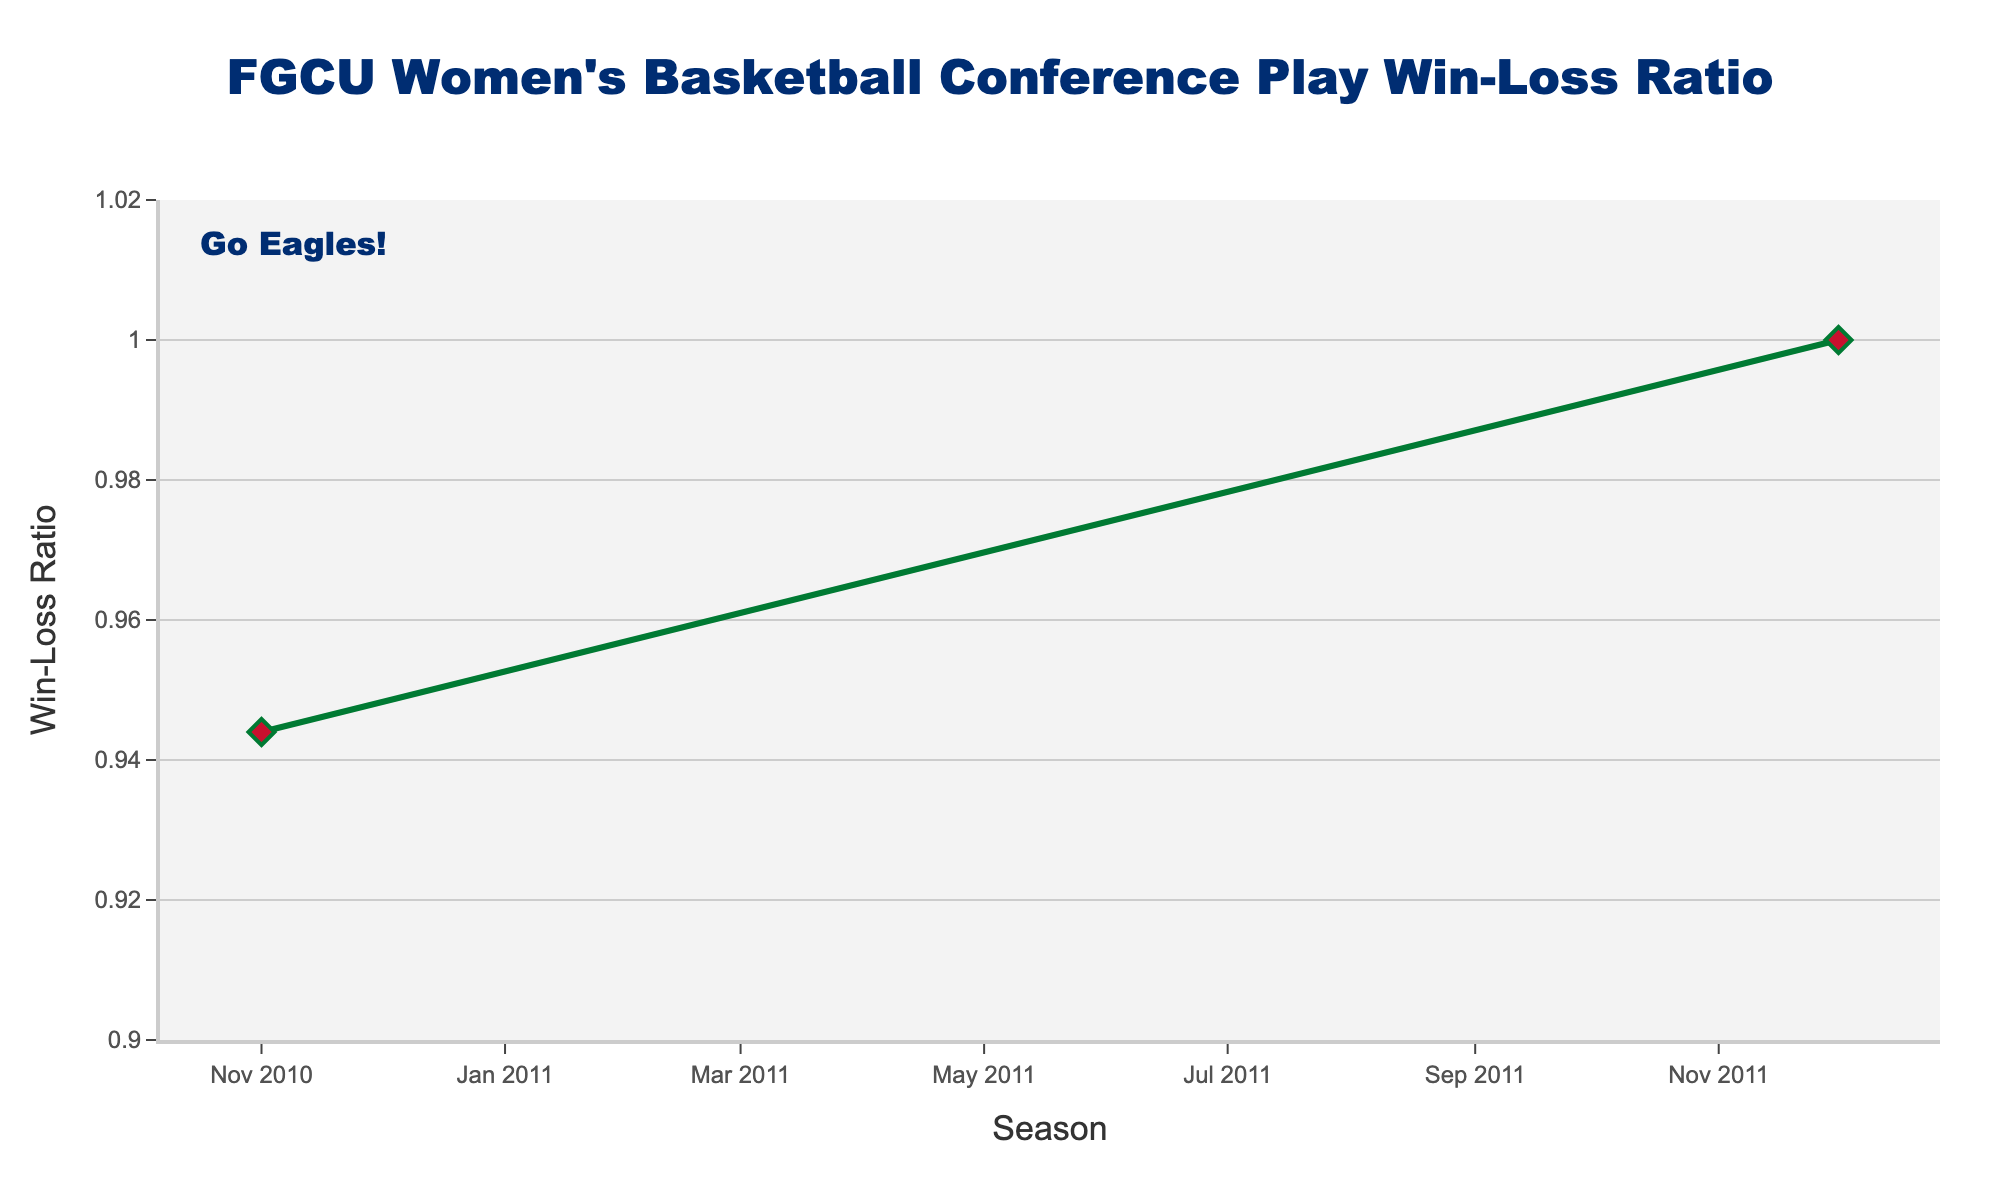What is the win-loss ratio for the 2014-15 season? Locate the point corresponding to the 2014-15 season on the x-axis and find the y-axis value, which is 1.000
Answer: 1.000 How many seasons have a perfect win-loss ratio of 1.000? Identify all the points on the line chart that are at the 1.000 mark on the y-axis (2011-12, 2012-13, 2014-15, 2015-16, 2018-19). There are five such seasons
Answer: 5 Which season has the lowest win-loss ratio? Find the point with the lowest y-axis value in the entire chart. The lowest win-loss ratio is 0.929, seen in the 2016-17 and 2017-18 seasons
Answer: 2016-17 and 2017-18 What is the average win-loss ratio for the seasons 2016-17, 2017-18, and 2019-20? Sum up the win-loss ratios for these seasons (0.929 + 0.929 + 0.933 = 2.791) and divide by the number of seasons, which is 3. So, the average is 2.791 / 3 ≈ 0.930
Answer: 0.930 Between which two consecutive seasons did the win-loss ratio increase the most? Calculate the differences between each pair of consecutive seasons and find the maximum difference. The largest increase is from 2010-11 (0.944) to 2011-12 (1.000), which is 1.000 - 0.944 = 0.056
Answer: 2010-11 to 2011-12 In which seasons did the win-loss ratio remain the same compared to the previous season? Identify points where the y-axis value is the same as the previous season. The win-loss ratio remained the same from 2016-17 to 2017-18 (both 0.929), and from 2020-21 to 2021-22 and 2022-23 (both 0.938)
Answer: 2016-17 to 2017-18, 2021-22 to 2022-23 How many times did the win-loss ratio reach 0.938? Count the number of occurrences of the win-loss ratio 0.938 on the y-axis. It appears in 2013-14, 2021-22, and 2022-23, which is three times
Answer: 3 What is the total sum of win-loss ratios across all seasons? Sum all the win-loss ratios: 0.944 + 1.000 + 1.000 + 0.938 + 1.000 + 1.000 + 0.929 + 0.929 + 1.000 + 0.933 + 0.933 + 0.938 + 0.938 = 12.482
Answer: 12.482 Which season had the highest win-loss ratio after the 2018-19 perfect season? Look for the highest y-axis value after the 2018-19 season. The highest win-loss ratio is 0.938 in 2021-22 and 2022-23
Answer: 2021-22 and 2022-23 What is the median win-loss ratio across the seasons? List all win-loss ratios in ascending order: (0.929, 0.929, 0.933, 0.933, 0.938, 0.938, 0.938, 0.944, 1.000, 1.000, 1.000, 1.000, 1.000). The median value is the middle one, which is 0.938
Answer: 0.938 